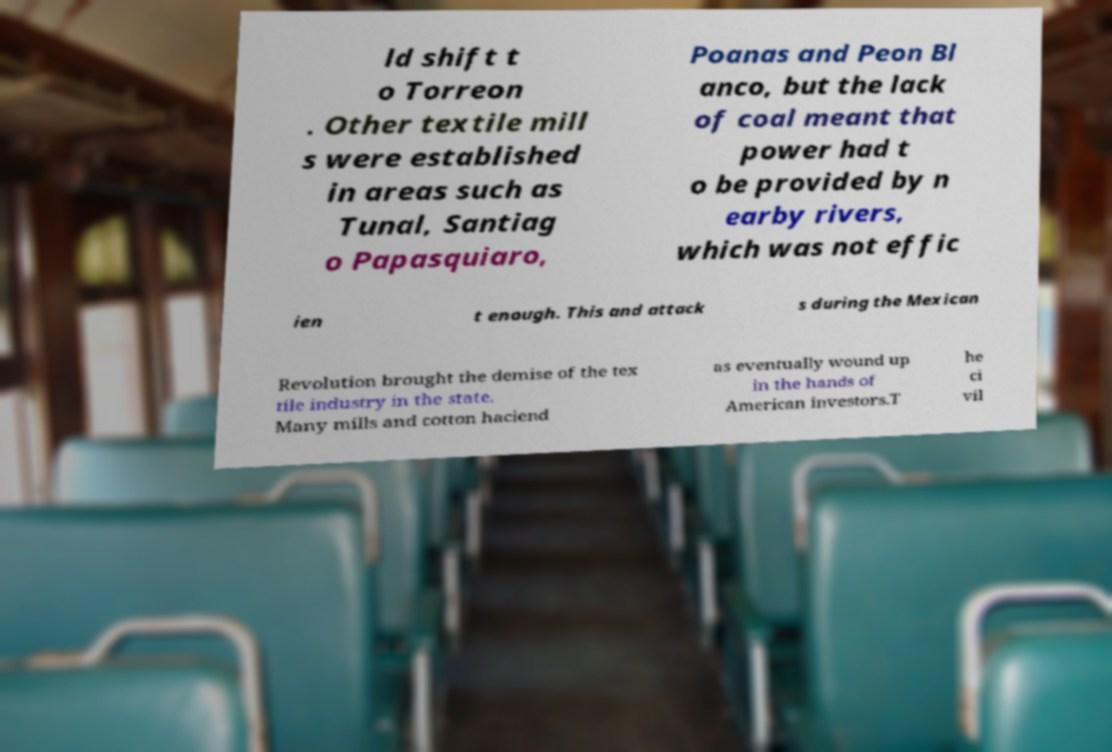For documentation purposes, I need the text within this image transcribed. Could you provide that? ld shift t o Torreon . Other textile mill s were established in areas such as Tunal, Santiag o Papasquiaro, Poanas and Peon Bl anco, but the lack of coal meant that power had t o be provided by n earby rivers, which was not effic ien t enough. This and attack s during the Mexican Revolution brought the demise of the tex tile industry in the state. Many mills and cotton haciend as eventually wound up in the hands of American investors.T he ci vil 